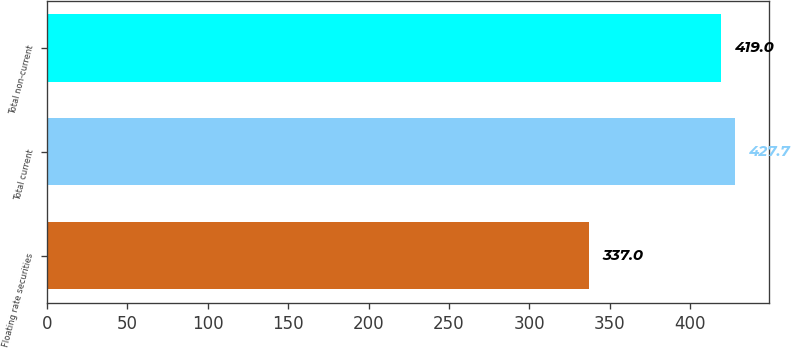Convert chart. <chart><loc_0><loc_0><loc_500><loc_500><bar_chart><fcel>Floating rate securities<fcel>Total current<fcel>Total non-current<nl><fcel>337<fcel>427.7<fcel>419<nl></chart> 